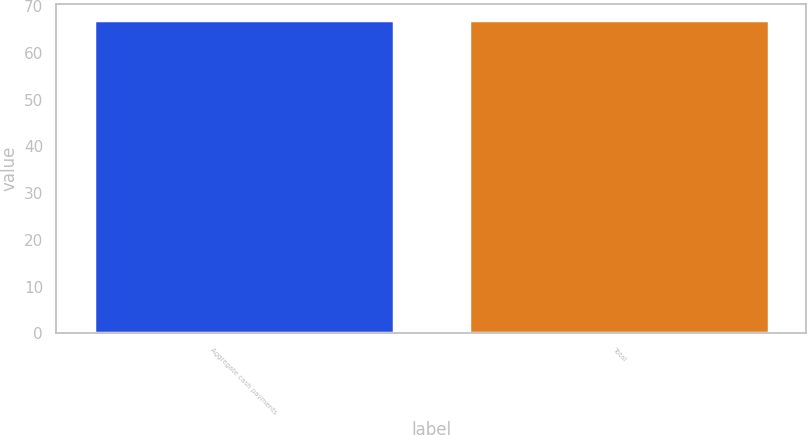Convert chart. <chart><loc_0><loc_0><loc_500><loc_500><bar_chart><fcel>Aggregate cash payments<fcel>Total<nl><fcel>67<fcel>67.1<nl></chart> 